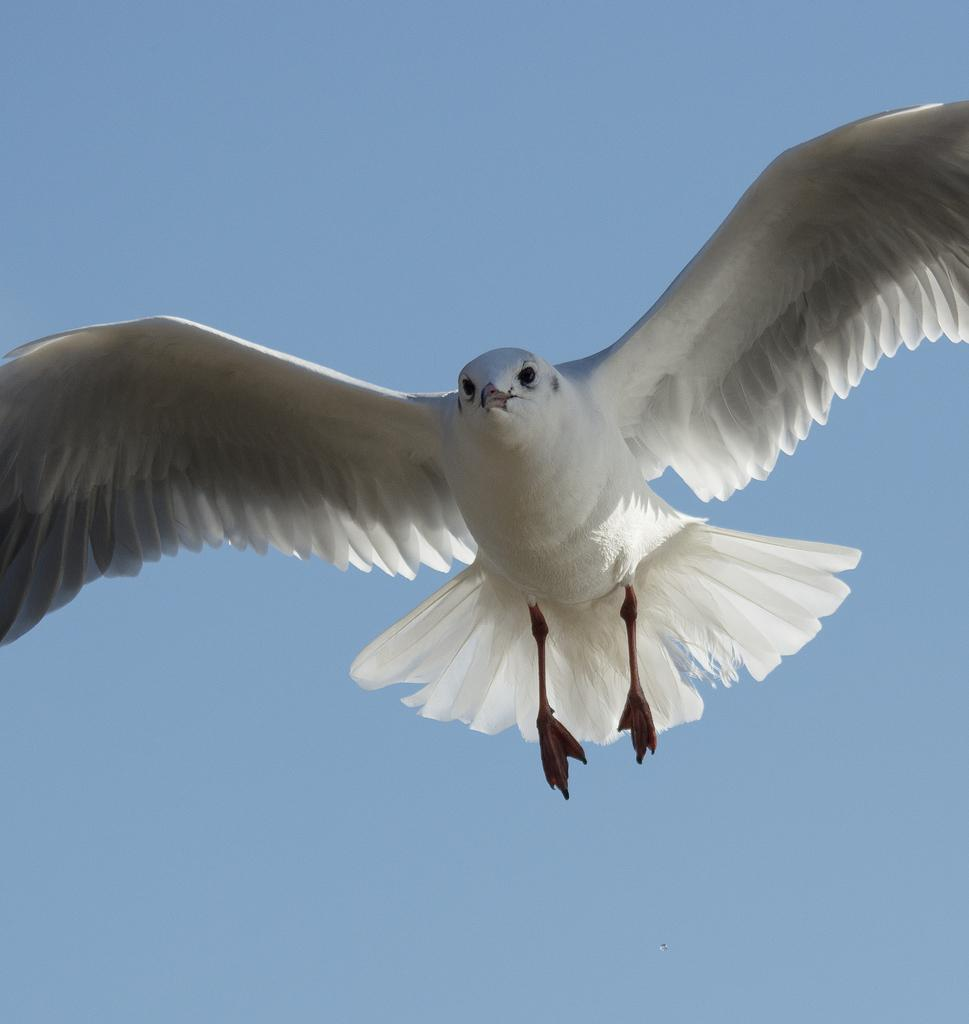What type of animal can be seen in the image? There is a bird in the image. What is the bird doing in the image? The bird is flying in the sky. How many friends is the bird playing with in the grass in the image? There are no friends or grass present in the image; it only features a bird flying in the sky. 